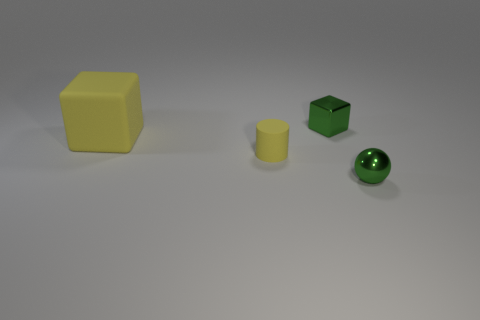There is a tiny green metal object on the right side of the small shiny cube; are there any yellow objects right of it?
Provide a succinct answer. No. What number of other things are the same shape as the large matte thing?
Provide a succinct answer. 1. Is the shape of the small yellow rubber thing the same as the large rubber thing?
Your answer should be very brief. No. There is a small thing that is both in front of the tiny block and to the left of the green metallic ball; what color is it?
Give a very brief answer. Yellow. What is the size of the matte cylinder that is the same color as the big rubber cube?
Ensure brevity in your answer.  Small. What number of large objects are blue rubber cylinders or metal spheres?
Give a very brief answer. 0. Are there any other things that are the same color as the matte cube?
Provide a succinct answer. Yes. There is a green thing that is left of the green thing that is in front of the green object to the left of the sphere; what is its material?
Your answer should be very brief. Metal. What number of rubber objects are either small cubes or large purple spheres?
Provide a short and direct response. 0. What number of red things are either big objects or rubber cylinders?
Provide a succinct answer. 0. 